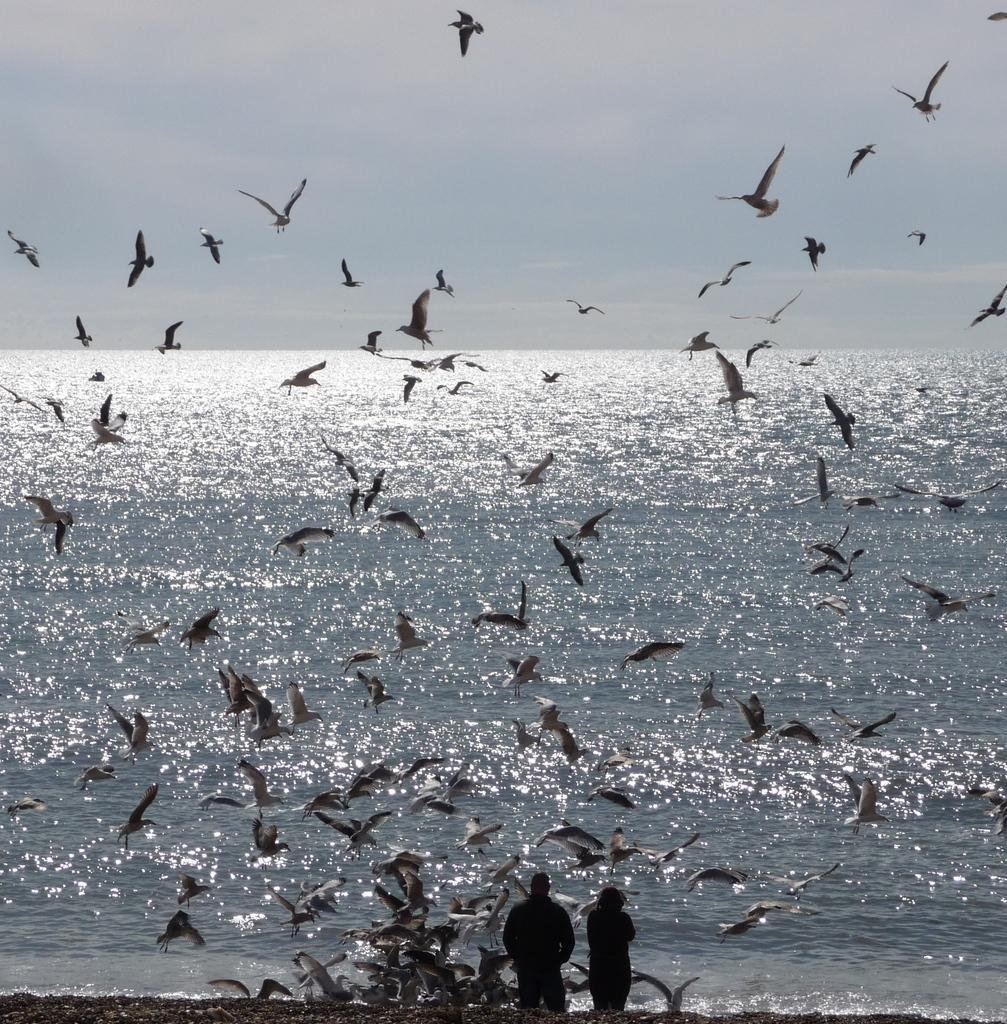Can you describe this image briefly? In this picture I see 2 persons in front and I see number of birds. In the background I see the water and I see the sky. 